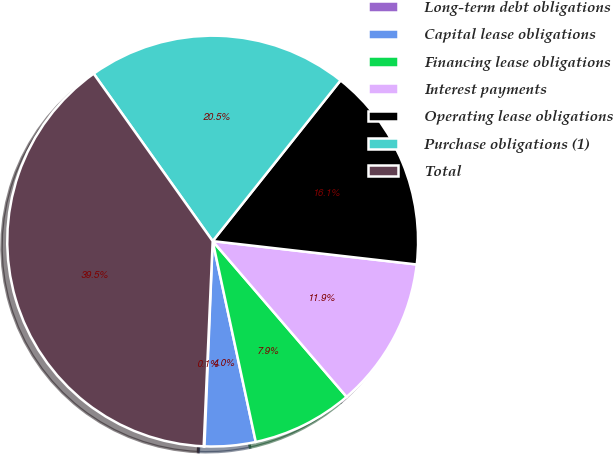Convert chart. <chart><loc_0><loc_0><loc_500><loc_500><pie_chart><fcel>Long-term debt obligations<fcel>Capital lease obligations<fcel>Financing lease obligations<fcel>Interest payments<fcel>Operating lease obligations<fcel>Purchase obligations (1)<fcel>Total<nl><fcel>0.06%<fcel>4.0%<fcel>7.94%<fcel>11.88%<fcel>16.12%<fcel>20.53%<fcel>39.47%<nl></chart> 